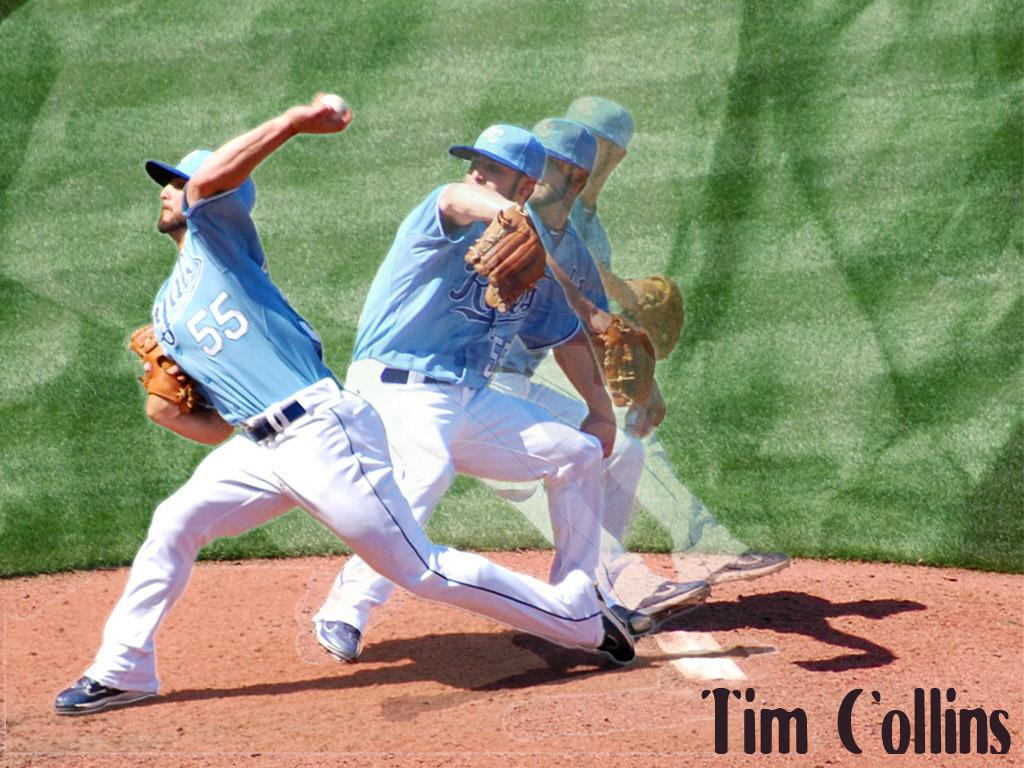Provide a one-sentence caption for the provided image. A baseball player is throwing a ball with 55 on his jersey. 